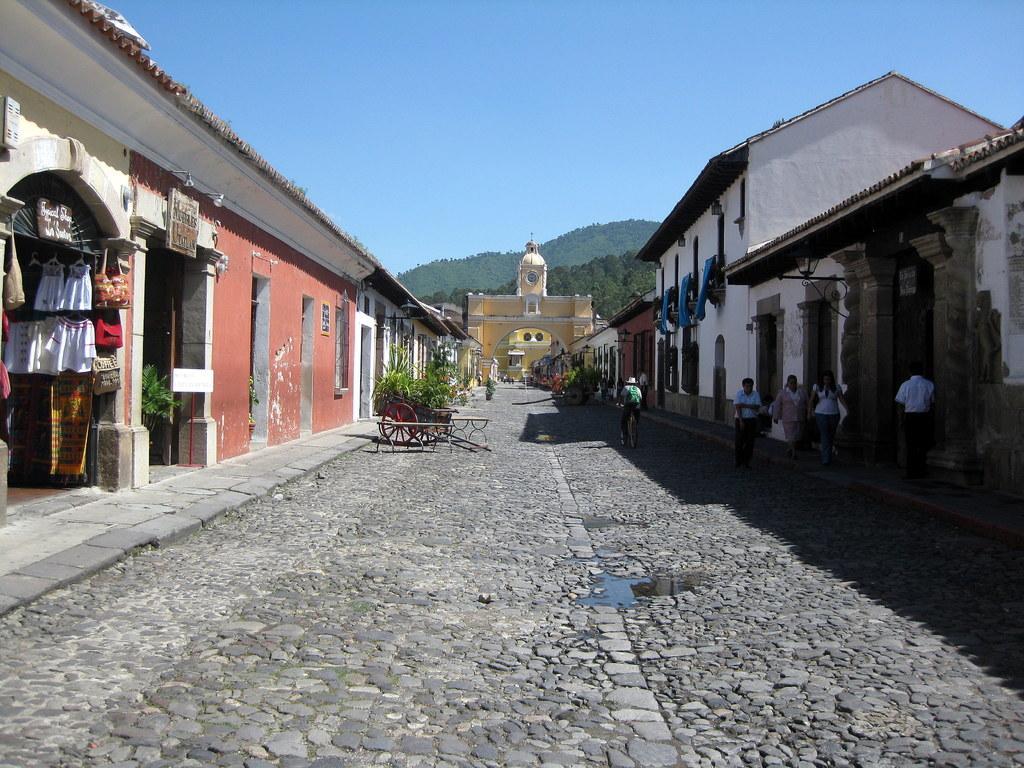In one or two sentences, can you explain what this image depicts? In the picture we can see a rock tiles pathway and on the other sides on the path we can see houses and shops and we can also see a cart and some plants near to it and in the background, we can see a gateway and behind it we can see hills with trees and sky and near the houses we can also see some people are walking. 